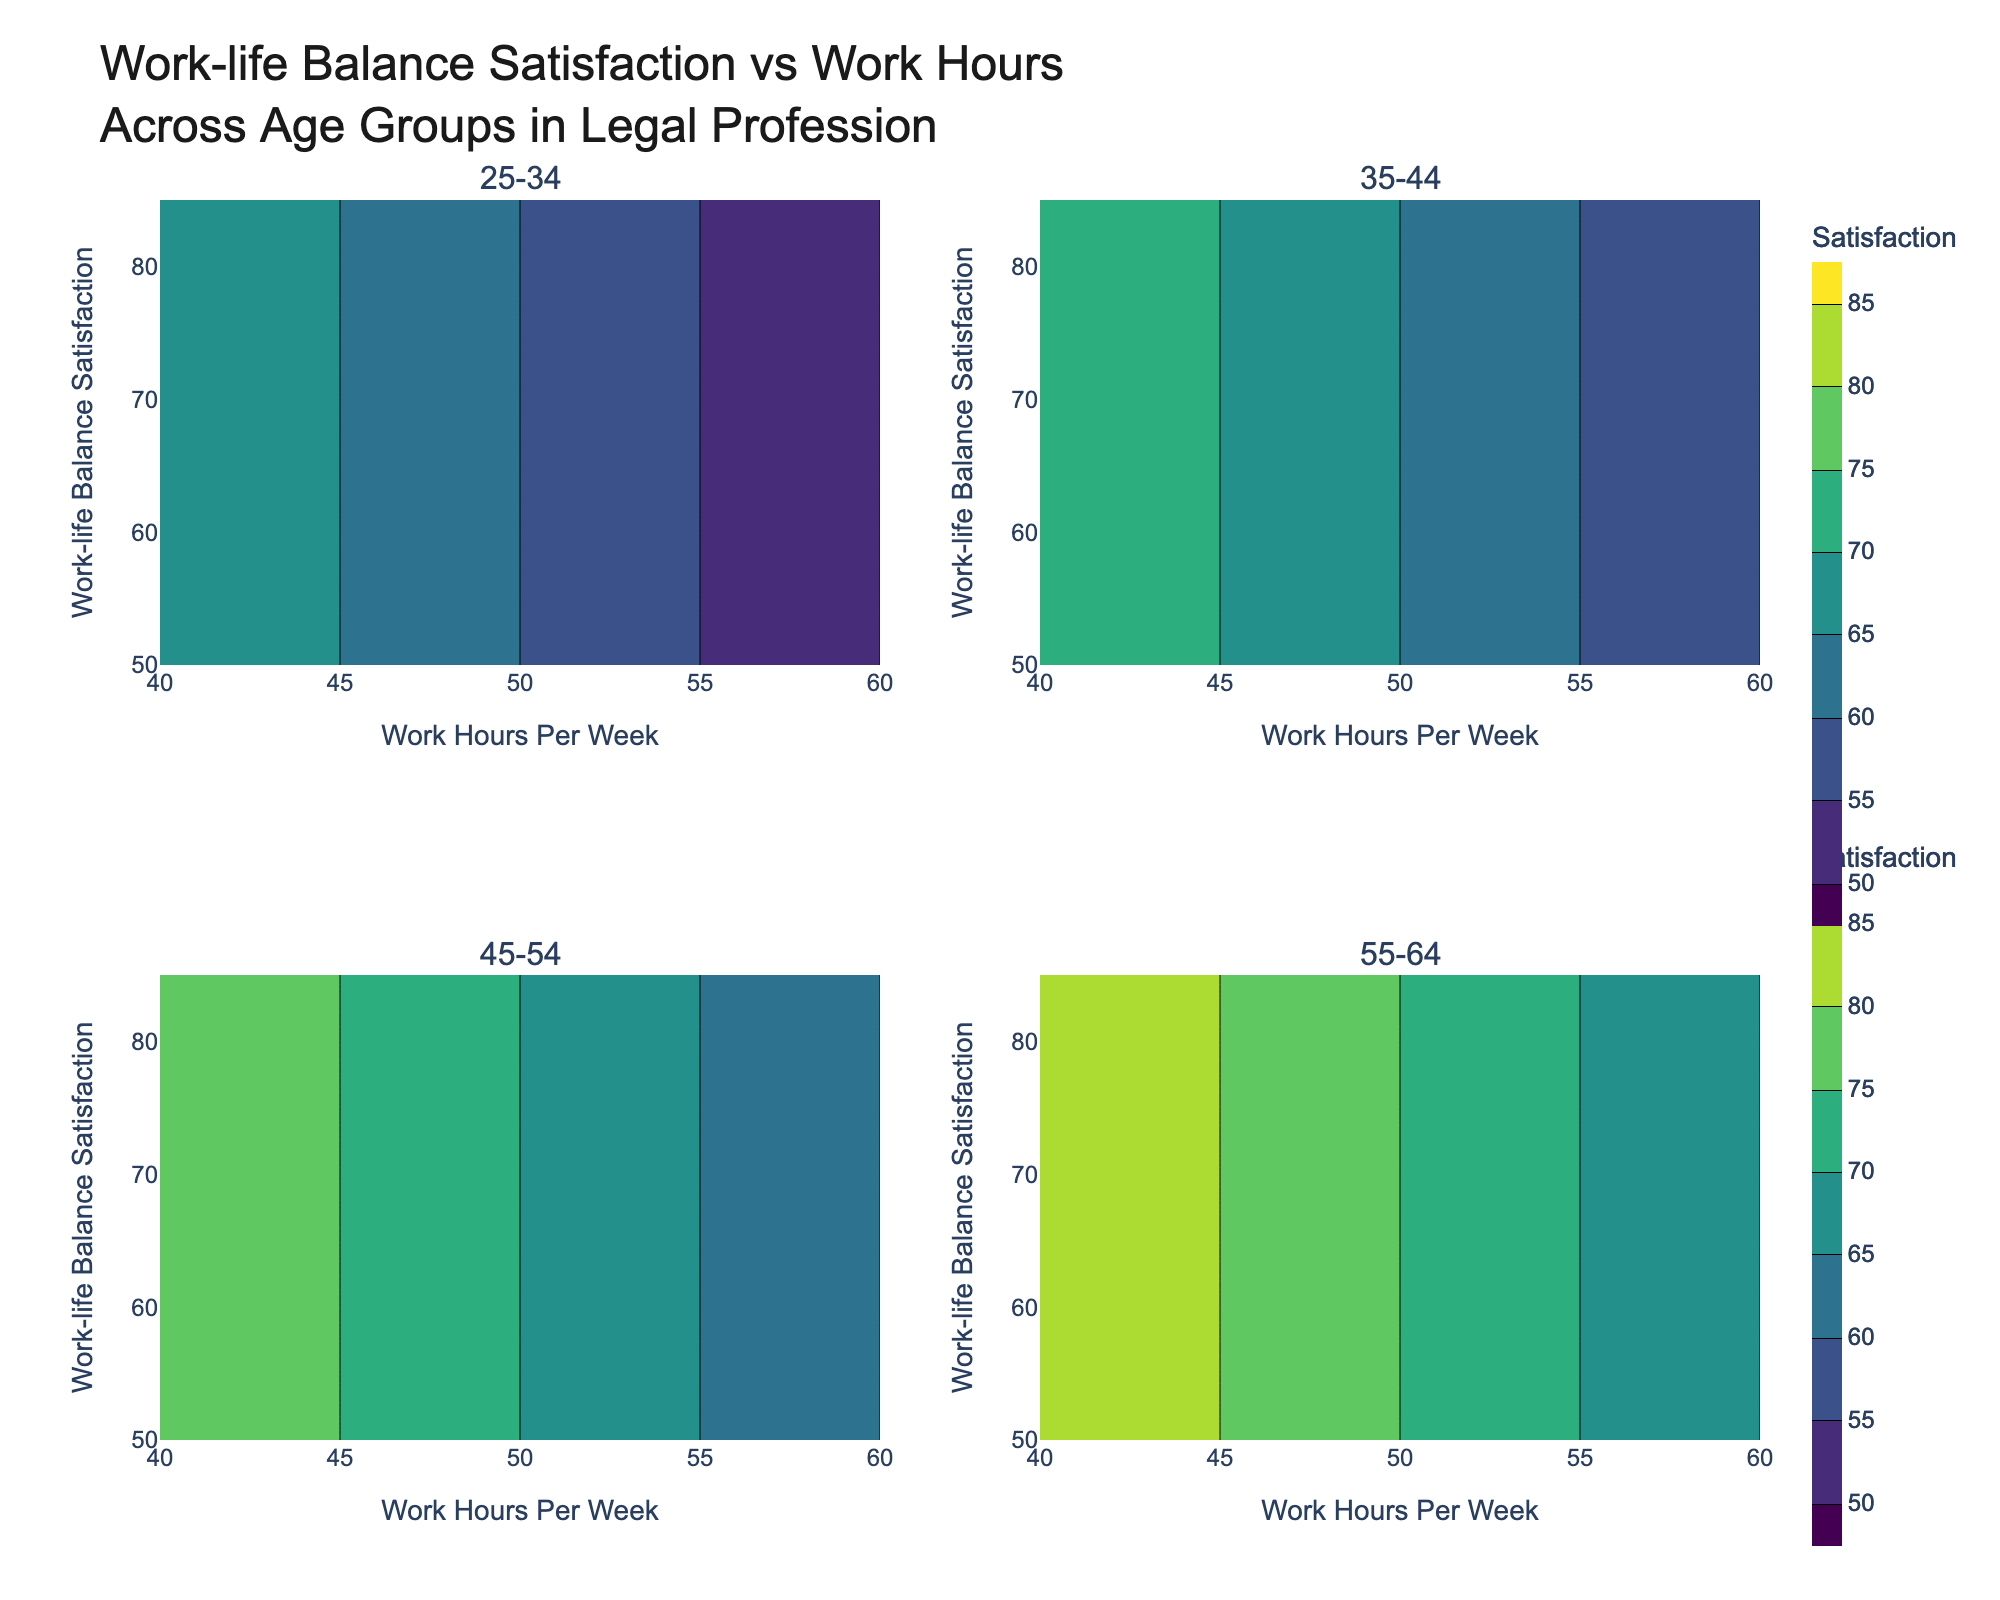what is the title of the figure? The title can be found at the top of the figure and it provides an overview of what the plot represents. In this case, the title is, "Work-life Balance Satisfaction vs Work Hours Across Age Groups in Legal Profession".
Answer: Work-life Balance Satisfaction vs Work Hours Across Age Groups in Legal Profession Which age group subplot shows the highest maximum satisfaction levels? In each subplot, look at the highest values indicated on the satisfaction axis and the contour color corresponding to that maximum. The subplot for the age group 55-64 shows the highest maximum satisfaction levels, reaching 85.
Answer: 55-64 Among the age groups, which one showed the least variation in work-life balance satisfaction across different work hours? Compare the range of satisfaction levels in each subplot. The 25-34 age group has a range from 50 to 70, which is the narrowest range compared to other groups that span larger satisfaction ranges.
Answer: 25-34 What is the general trend between work hours and work-life balance satisfaction for the age group 35-44? Observe the contour lines in the subplot for the age group 35-44. The trend shows that as the work hours increase, the work-life balance satisfaction decreases. This is reflected in the contour lines indicating lower satisfaction levels with increased hours.
Answer: Decreasing Which age group maintains high work-life balance satisfaction (above 70) despite varying work hours, based on the contour shades? Examine each subplot to see which age group maintains a satisfaction level above 70 across different work hours. The 45-54 age group maintains satisfaction above 70 even at higher work hours, as indicated by lighter contour shades.
Answer: 45-54 For the age group 55-64, what work hours correspond to a satisfaction level of approximately 75? In the 55-64 subplot, find the contour line that corresponds to a satisfaction level of 75, then look at the x-axis to see the work hours. The work hours corresponding to a satisfaction level of approximately 75 are around 50 hours per week.
Answer: 50 hours per week How does the contour color change from 40 to 60 work hours for the age group 25-34? Observing the transition of colors in the subplot for 25-34, the contour color changes from a lighter shade to a darker one as work hours increase from 40 to 60, indicating a decrease in satisfaction levels.
Answer: From light to dark Which subplot shows the least work-life balance satisfaction at 60 work hours per week? By comparing the subplots at the 60 work hours mark, the 25-34 age group shows the least work-life balance satisfaction, indicated by the darkest contour shade at this point.
Answer: 25-34 What specific contour lines are used for satisfaction levels in this plot? The contours are defined at intervals starting from 50 and increasing by 5 up to 85, as indicated by the legend in each subplot.
Answer: 50, 55, 60, 65, 70, 75, 80, 85 In the age group 45-54, what work hours range mostly results in satisfaction levels above 75? Check the 45-54 subplot for the contours that are above the 75 satisfaction level and trace these contours to the corresponding work hours on the x-axis. Satisfaction levels above 75 are mostly seen between 40 and 50 work hours per week.
Answer: 40-50 hours per week 